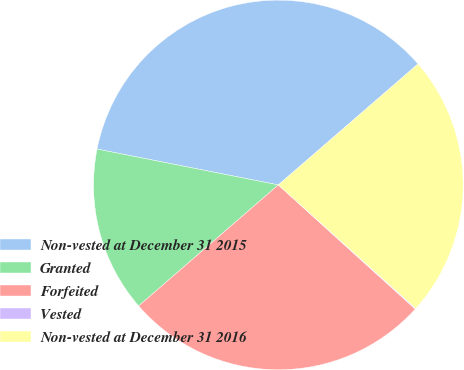Convert chart to OTSL. <chart><loc_0><loc_0><loc_500><loc_500><pie_chart><fcel>Non-vested at December 31 2015<fcel>Granted<fcel>Forfeited<fcel>Vested<fcel>Non-vested at December 31 2016<nl><fcel>35.53%<fcel>14.47%<fcel>26.91%<fcel>0.07%<fcel>23.01%<nl></chart> 